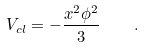<formula> <loc_0><loc_0><loc_500><loc_500>V _ { c l } = - \frac { x ^ { 2 } \phi ^ { 2 } } { 3 } \quad .</formula> 